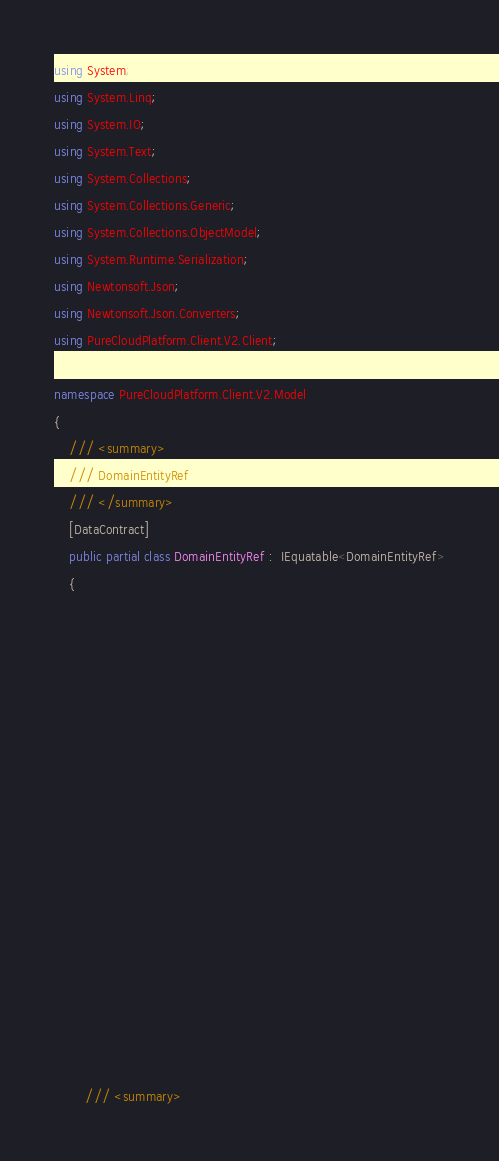Convert code to text. <code><loc_0><loc_0><loc_500><loc_500><_C#_>using System;
using System.Linq;
using System.IO;
using System.Text;
using System.Collections;
using System.Collections.Generic;
using System.Collections.ObjectModel;
using System.Runtime.Serialization;
using Newtonsoft.Json;
using Newtonsoft.Json.Converters;
using PureCloudPlatform.Client.V2.Client;

namespace PureCloudPlatform.Client.V2.Model
{
    /// <summary>
    /// DomainEntityRef
    /// </summary>
    [DataContract]
    public partial class DomainEntityRef :  IEquatable<DomainEntityRef>
    {
        
        
        
        
        
        
        
        
        
        
        
        
        
        
        
        
        
    
        /// <summary></code> 